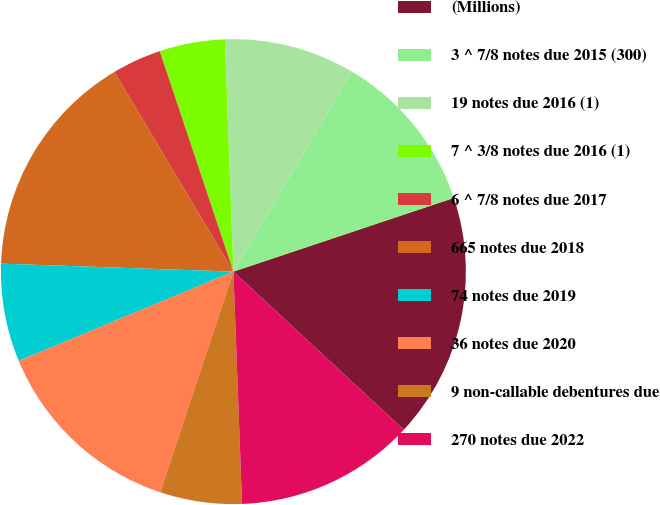<chart> <loc_0><loc_0><loc_500><loc_500><pie_chart><fcel>(Millions)<fcel>3 ^ 7/8 notes due 2015 (300)<fcel>19 notes due 2016 (1)<fcel>7 ^ 3/8 notes due 2016 (1)<fcel>6 ^ 7/8 notes due 2017<fcel>665 notes due 2018<fcel>74 notes due 2019<fcel>36 notes due 2020<fcel>9 non-callable debentures due<fcel>270 notes due 2022<nl><fcel>17.04%<fcel>11.36%<fcel>9.09%<fcel>4.55%<fcel>3.42%<fcel>15.9%<fcel>6.82%<fcel>13.63%<fcel>5.69%<fcel>12.5%<nl></chart> 